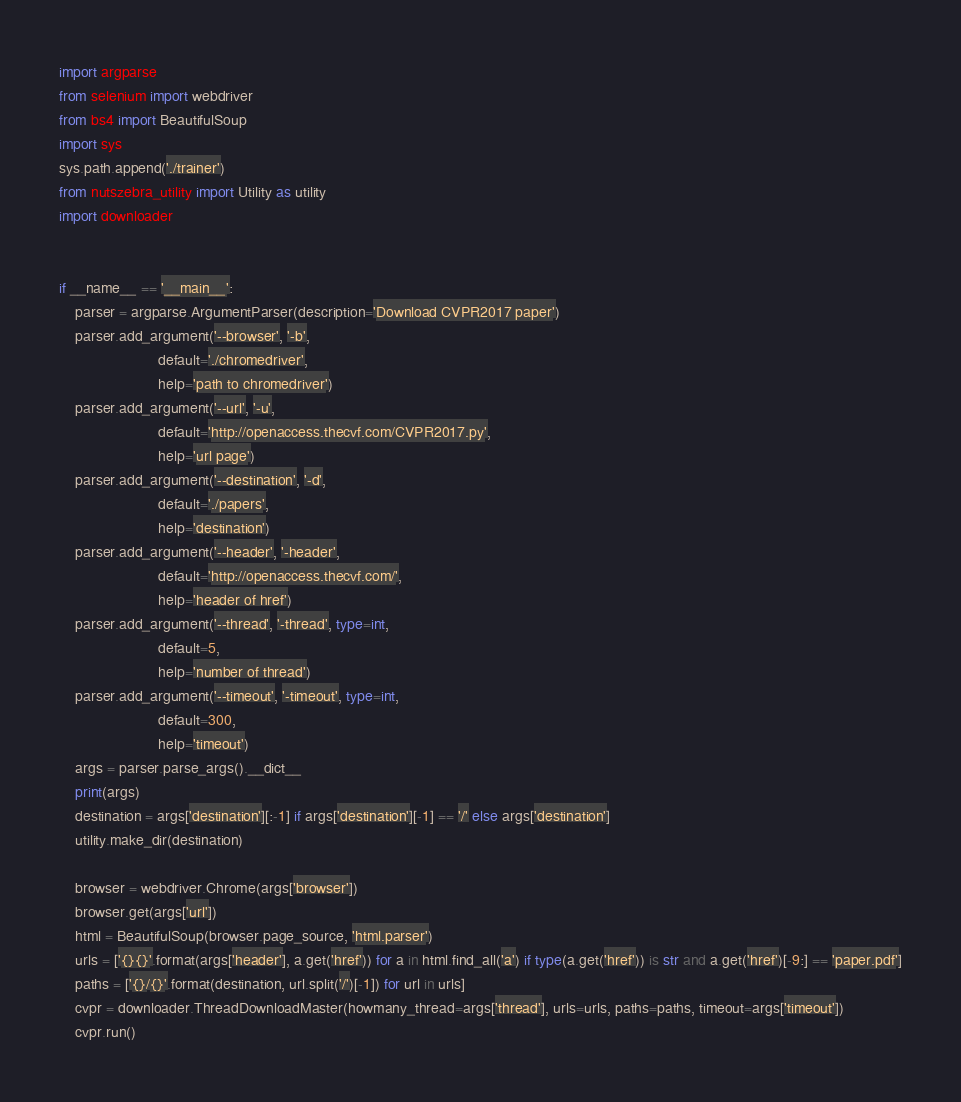<code> <loc_0><loc_0><loc_500><loc_500><_Python_>import argparse
from selenium import webdriver
from bs4 import BeautifulSoup
import sys
sys.path.append('./trainer')
from nutszebra_utility import Utility as utility
import downloader


if __name__ == '__main__':
    parser = argparse.ArgumentParser(description='Download CVPR2017 paper')
    parser.add_argument('--browser', '-b',
                        default='./chromedriver',
                        help='path to chromedriver')
    parser.add_argument('--url', '-u',
                        default='http://openaccess.thecvf.com/CVPR2017.py',
                        help='url page')
    parser.add_argument('--destination', '-d',
                        default='./papers',
                        help='destination')
    parser.add_argument('--header', '-header',
                        default='http://openaccess.thecvf.com/',
                        help='header of href')
    parser.add_argument('--thread', '-thread', type=int,
                        default=5,
                        help='number of thread')
    parser.add_argument('--timeout', '-timeout', type=int,
                        default=300,
                        help='timeout')
    args = parser.parse_args().__dict__
    print(args)
    destination = args['destination'][:-1] if args['destination'][-1] == '/' else args['destination']
    utility.make_dir(destination)

    browser = webdriver.Chrome(args['browser'])
    browser.get(args['url'])
    html = BeautifulSoup(browser.page_source, 'html.parser')
    urls = ['{}{}'.format(args['header'], a.get('href')) for a in html.find_all('a') if type(a.get('href')) is str and a.get('href')[-9:] == 'paper.pdf']
    paths = ['{}/{}'.format(destination, url.split('/')[-1]) for url in urls]
    cvpr = downloader.ThreadDownloadMaster(howmany_thread=args['thread'], urls=urls, paths=paths, timeout=args['timeout'])
    cvpr.run()
</code> 